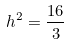<formula> <loc_0><loc_0><loc_500><loc_500>h ^ { 2 } = \frac { 1 6 } { 3 }</formula> 